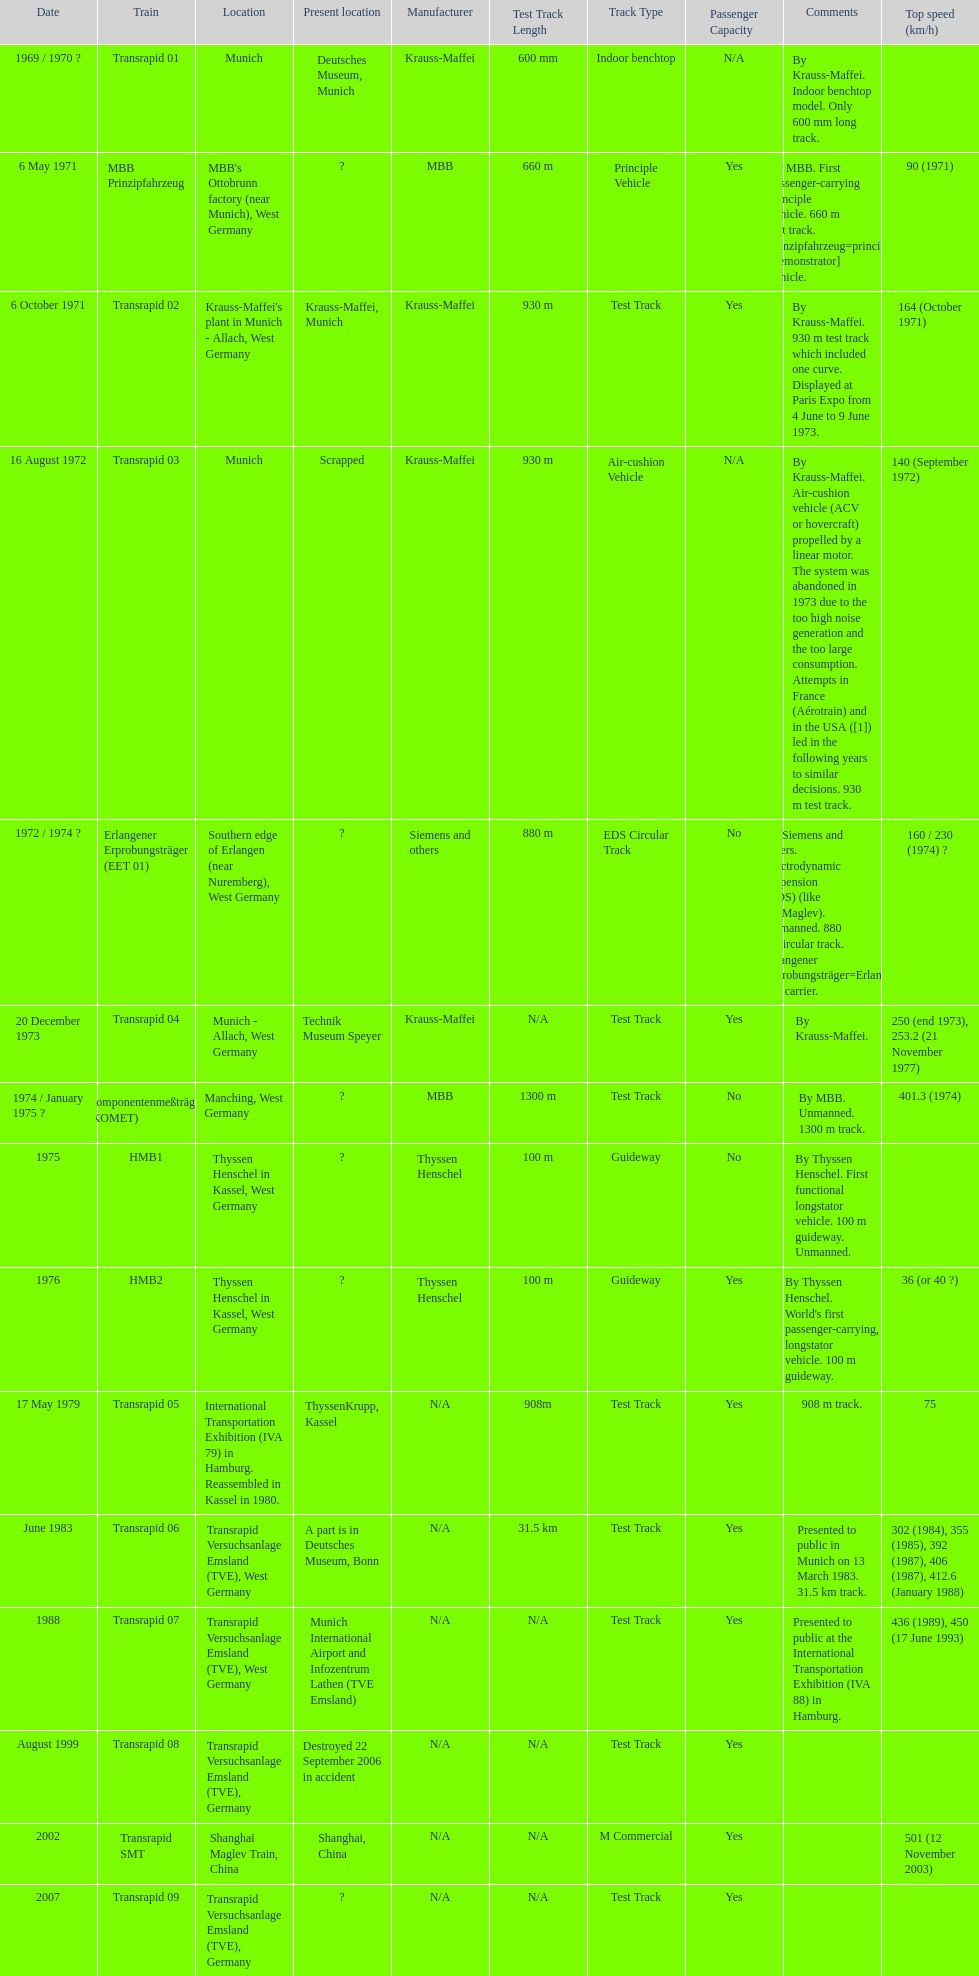What is the count of trains that were either dismantled or demolished? 2. 